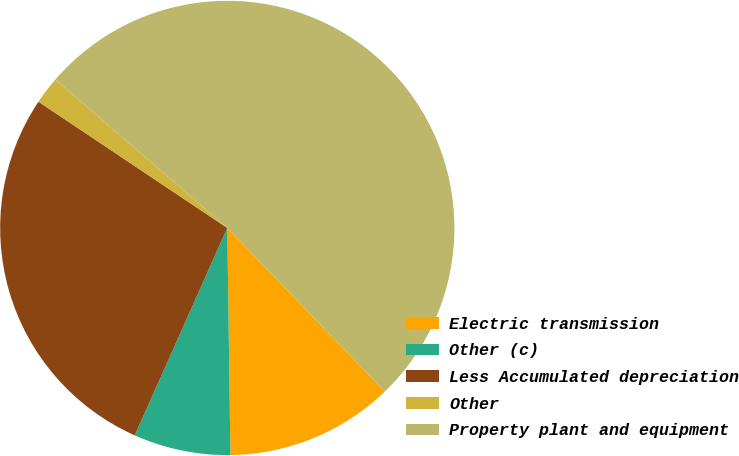Convert chart to OTSL. <chart><loc_0><loc_0><loc_500><loc_500><pie_chart><fcel>Electric transmission<fcel>Other (c)<fcel>Less Accumulated depreciation<fcel>Other<fcel>Property plant and equipment<nl><fcel>11.98%<fcel>6.9%<fcel>27.7%<fcel>1.95%<fcel>51.47%<nl></chart> 